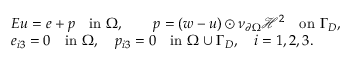Convert formula to latex. <formula><loc_0><loc_0><loc_500><loc_500>\begin{array} { r l } & { E u = e + p \quad i n \Omega , \quad p = ( w - u ) \odot \nu _ { \partial \Omega } \mathcal { H } ^ { 2 } \quad o n \Gamma _ { D } , } \\ & { e _ { i 3 } = 0 \quad i n \Omega , \quad p _ { i 3 } = 0 \quad i n \Omega \cup \Gamma _ { D } , \quad i = 1 , 2 , 3 . } \end{array}</formula> 